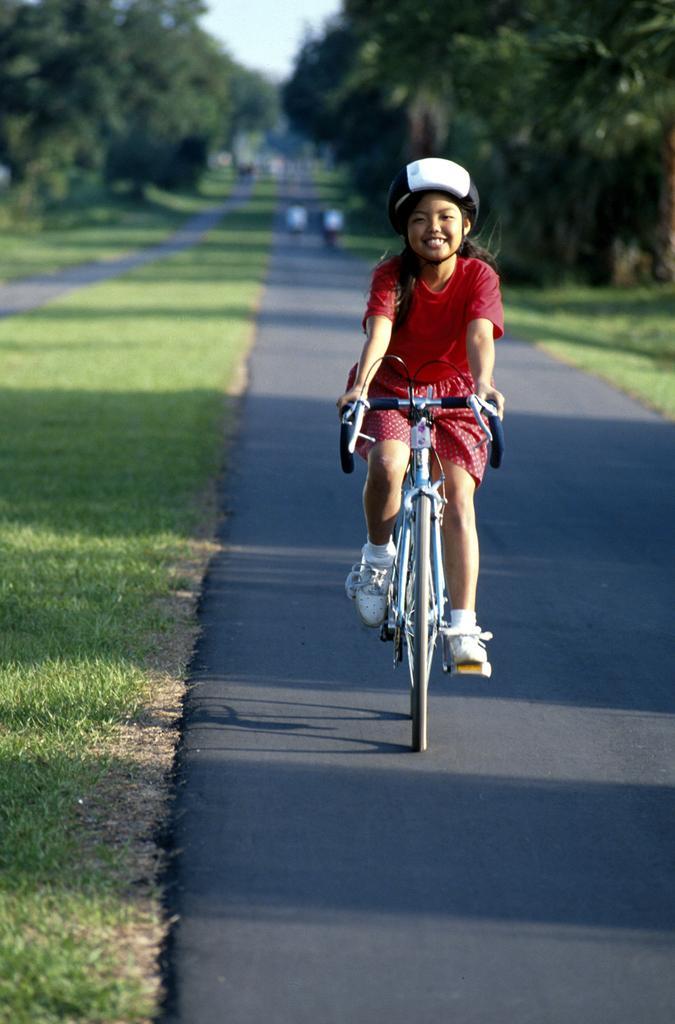Can you describe this image briefly? In this picture there is a girl who is riding bicycle. This girl is wearing red color top and bottom i. e. short and she is wearing a shoe a white colored one. She also wears a hat and she is riding on the road. Behind the road there is grass present. At the background, we can see the trees left and right of the road and the sky in the middle. 